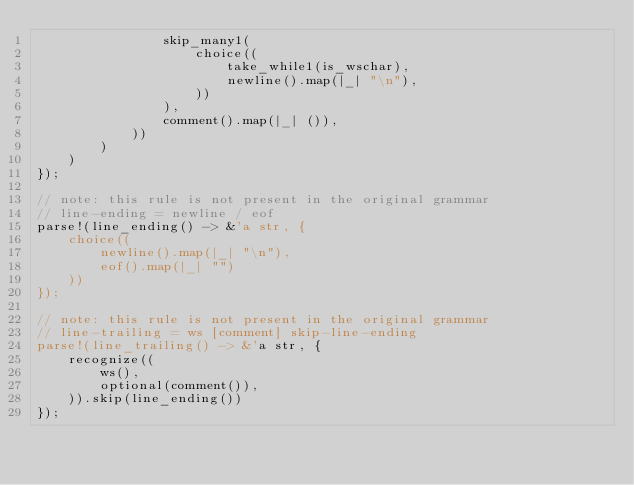Convert code to text. <code><loc_0><loc_0><loc_500><loc_500><_Rust_>                skip_many1(
                    choice((
                        take_while1(is_wschar),
                        newline().map(|_| "\n"),
                    ))
                ),
                comment().map(|_| ()),
            ))
        )
    )
});

// note: this rule is not present in the original grammar
// line-ending = newline / eof
parse!(line_ending() -> &'a str, {
    choice((
        newline().map(|_| "\n"),
        eof().map(|_| "")
    ))
});

// note: this rule is not present in the original grammar
// line-trailing = ws [comment] skip-line-ending
parse!(line_trailing() -> &'a str, {
    recognize((
        ws(),
        optional(comment()),
    )).skip(line_ending())
});
</code> 